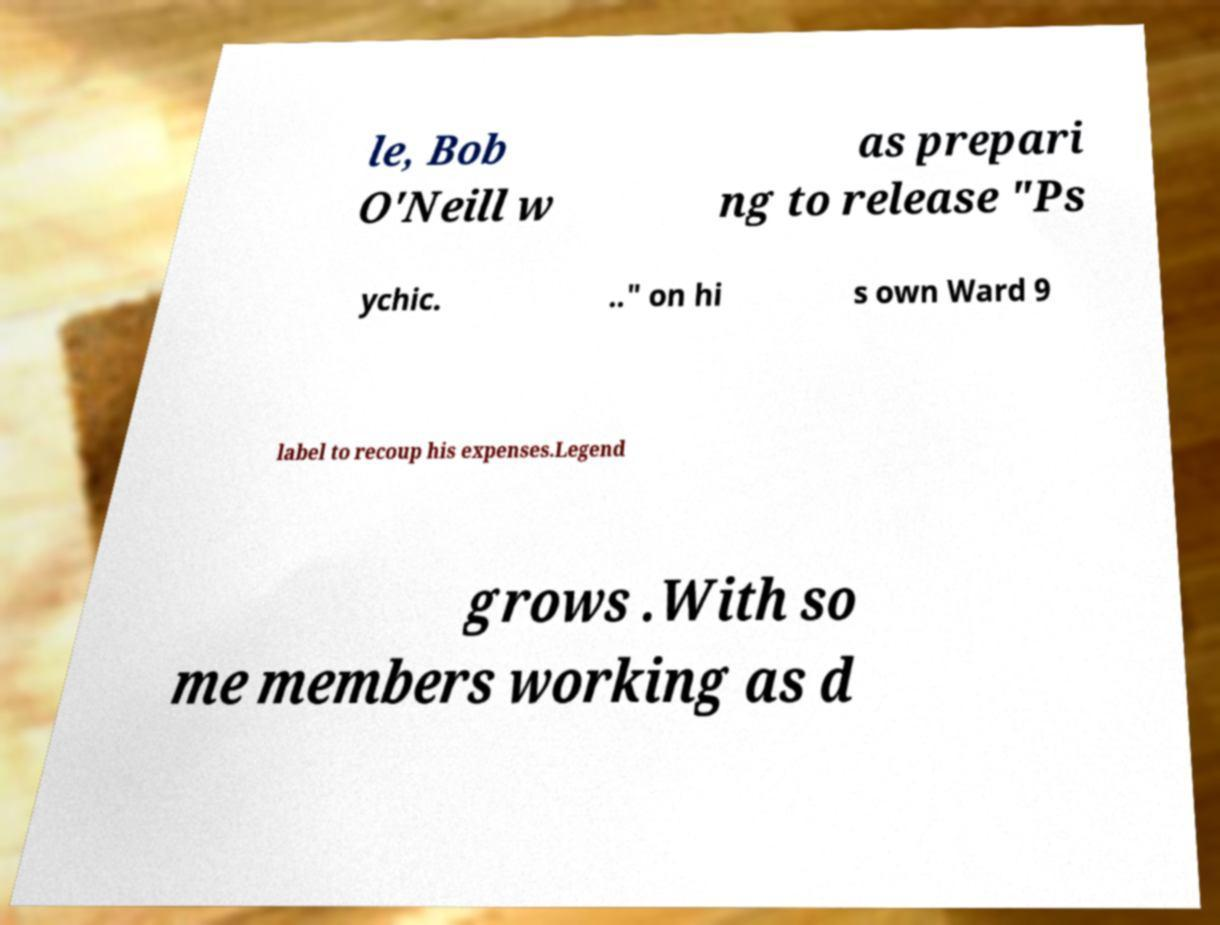Can you read and provide the text displayed in the image?This photo seems to have some interesting text. Can you extract and type it out for me? le, Bob O'Neill w as prepari ng to release "Ps ychic. .." on hi s own Ward 9 label to recoup his expenses.Legend grows .With so me members working as d 